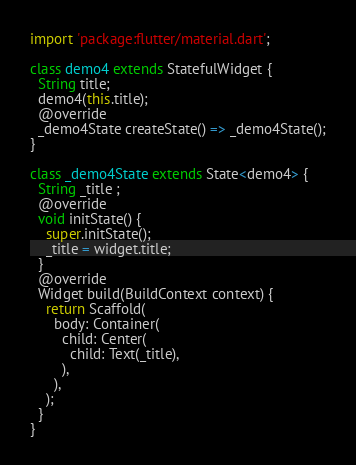Convert code to text. <code><loc_0><loc_0><loc_500><loc_500><_Dart_>import 'package:flutter/material.dart';

class demo4 extends StatefulWidget {
  String title;
  demo4(this.title);
  @override
  _demo4State createState() => _demo4State();
}

class _demo4State extends State<demo4> {
  String _title ;
  @override
  void initState() {
    super.initState();
    _title = widget.title;
  }
  @override
  Widget build(BuildContext context) {
    return Scaffold(
      body: Container(
        child: Center(
          child: Text(_title),
        ),
      ),
    );
  }
}</code> 